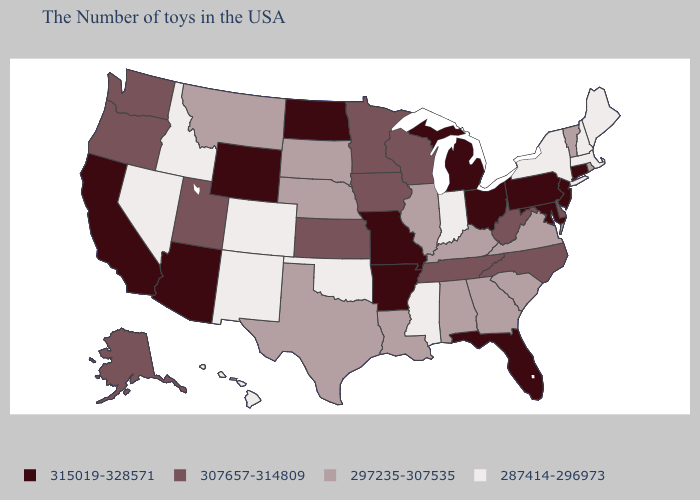Which states have the lowest value in the MidWest?
Give a very brief answer. Indiana. Does New York have the highest value in the Northeast?
Quick response, please. No. What is the value of South Dakota?
Concise answer only. 297235-307535. Which states hav the highest value in the South?
Quick response, please. Maryland, Florida, Arkansas. Does the first symbol in the legend represent the smallest category?
Quick response, please. No. What is the value of Florida?
Concise answer only. 315019-328571. What is the value of Michigan?
Be succinct. 315019-328571. Among the states that border New Mexico , does Texas have the highest value?
Be succinct. No. Among the states that border Kansas , does Missouri have the highest value?
Write a very short answer. Yes. Which states hav the highest value in the South?
Concise answer only. Maryland, Florida, Arkansas. What is the highest value in states that border Connecticut?
Quick response, please. 297235-307535. Does the first symbol in the legend represent the smallest category?
Write a very short answer. No. What is the value of West Virginia?
Write a very short answer. 307657-314809. Name the states that have a value in the range 315019-328571?
Short answer required. Connecticut, New Jersey, Maryland, Pennsylvania, Ohio, Florida, Michigan, Missouri, Arkansas, North Dakota, Wyoming, Arizona, California. Does Wisconsin have the same value as Arizona?
Be succinct. No. 